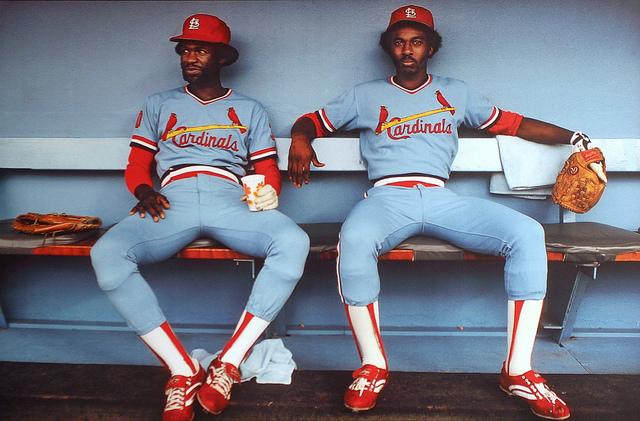What color are the stripes on the boys shoes?
Answer briefly. White. Is this picture from the 70s?
Give a very brief answer. Yes. Is this a past event?
Be succinct. Yes. What team do these guys play for?
Quick response, please. Cardinals. 